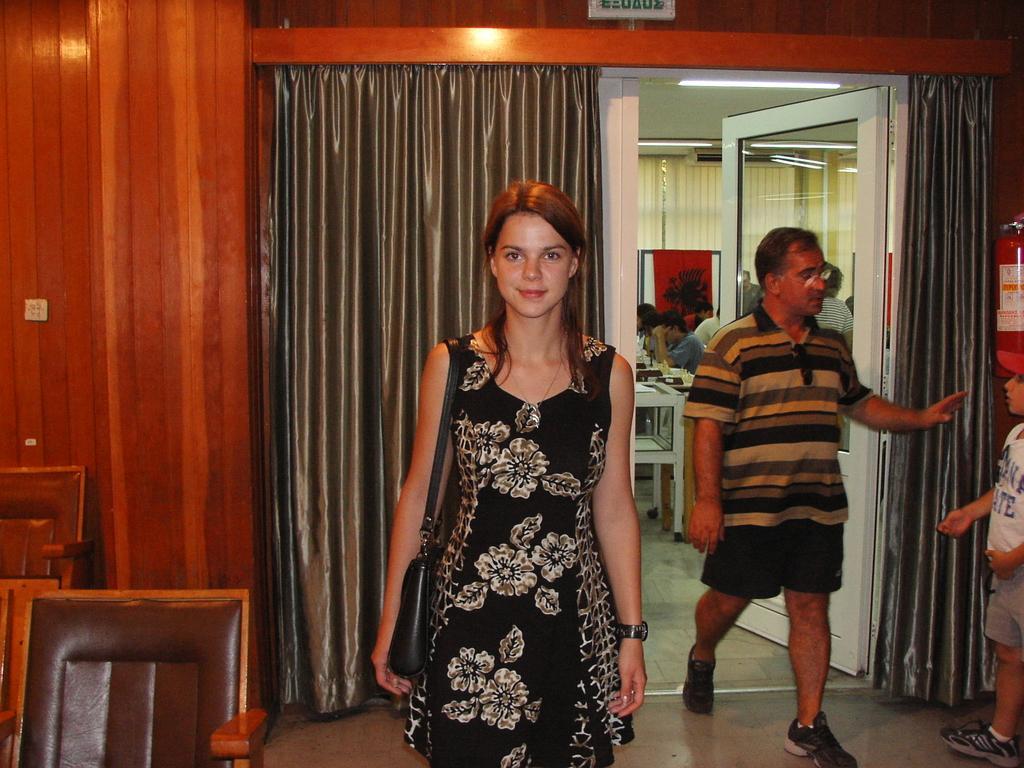Can you describe this image briefly? In this image in the foreground there is one woman who is standing, and in the background there is one man who is walking. On the right side there is one boy and in the background there are some people who are sitting, and also there are some tables. On the right side there is a wooden wall and in the center there is a glass door and some curtains, at the bottom there are some chairs and a floor. 